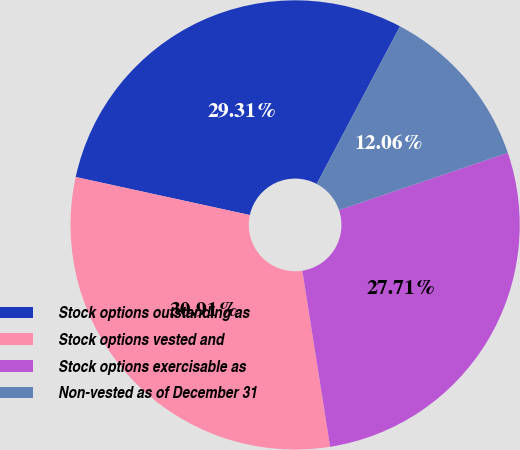Convert chart to OTSL. <chart><loc_0><loc_0><loc_500><loc_500><pie_chart><fcel>Stock options outstanding as<fcel>Stock options vested and<fcel>Stock options exercisable as<fcel>Non-vested as of December 31<nl><fcel>29.31%<fcel>30.91%<fcel>27.71%<fcel>12.06%<nl></chart> 